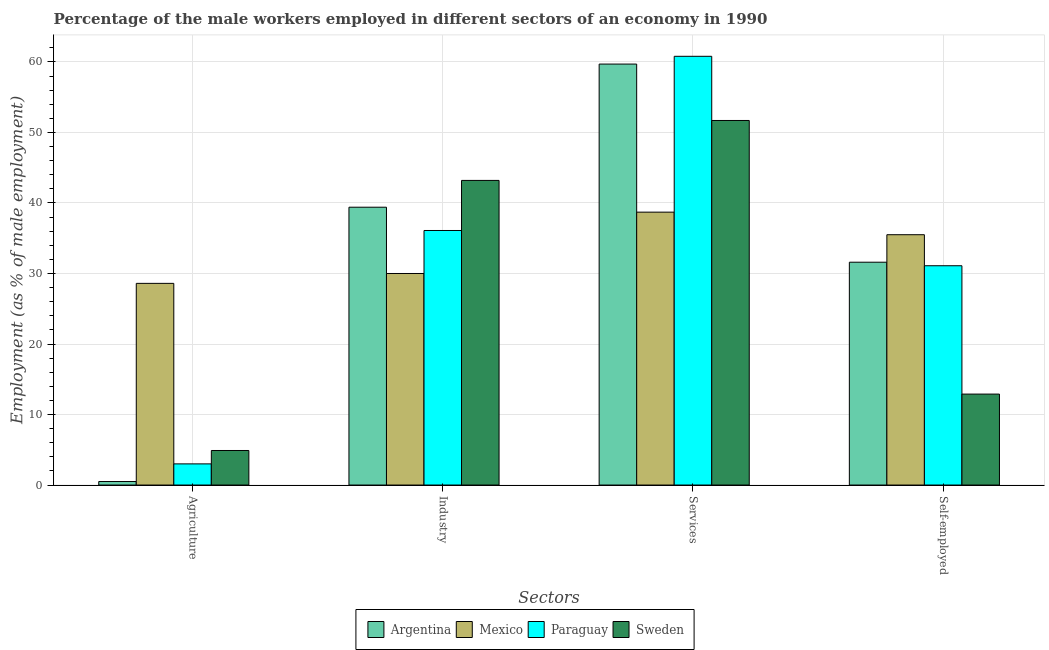How many different coloured bars are there?
Provide a succinct answer. 4. How many groups of bars are there?
Offer a very short reply. 4. Are the number of bars per tick equal to the number of legend labels?
Provide a succinct answer. Yes. Are the number of bars on each tick of the X-axis equal?
Your response must be concise. Yes. How many bars are there on the 1st tick from the left?
Your answer should be very brief. 4. How many bars are there on the 3rd tick from the right?
Provide a succinct answer. 4. What is the label of the 1st group of bars from the left?
Make the answer very short. Agriculture. What is the percentage of self employed male workers in Argentina?
Your answer should be very brief. 31.6. Across all countries, what is the maximum percentage of male workers in industry?
Your answer should be very brief. 43.2. Across all countries, what is the minimum percentage of male workers in agriculture?
Give a very brief answer. 0.5. In which country was the percentage of self employed male workers maximum?
Keep it short and to the point. Mexico. In which country was the percentage of male workers in services minimum?
Provide a succinct answer. Mexico. What is the total percentage of male workers in industry in the graph?
Your response must be concise. 148.7. What is the difference between the percentage of self employed male workers in Paraguay and that in Mexico?
Offer a terse response. -4.4. What is the difference between the percentage of male workers in agriculture in Sweden and the percentage of male workers in services in Mexico?
Provide a succinct answer. -33.8. What is the average percentage of male workers in agriculture per country?
Ensure brevity in your answer.  9.25. What is the difference between the percentage of self employed male workers and percentage of male workers in industry in Sweden?
Your answer should be very brief. -30.3. What is the ratio of the percentage of self employed male workers in Mexico to that in Paraguay?
Offer a very short reply. 1.14. Is the percentage of male workers in agriculture in Mexico less than that in Paraguay?
Give a very brief answer. No. What is the difference between the highest and the second highest percentage of male workers in agriculture?
Your answer should be compact. 23.7. What is the difference between the highest and the lowest percentage of male workers in industry?
Provide a short and direct response. 13.2. Is the sum of the percentage of self employed male workers in Paraguay and Mexico greater than the maximum percentage of male workers in services across all countries?
Give a very brief answer. Yes. What does the 2nd bar from the left in Services represents?
Your answer should be compact. Mexico. Is it the case that in every country, the sum of the percentage of male workers in agriculture and percentage of male workers in industry is greater than the percentage of male workers in services?
Give a very brief answer. No. How many bars are there?
Provide a succinct answer. 16. What is the difference between two consecutive major ticks on the Y-axis?
Make the answer very short. 10. Does the graph contain any zero values?
Offer a very short reply. No. Does the graph contain grids?
Provide a short and direct response. Yes. What is the title of the graph?
Provide a succinct answer. Percentage of the male workers employed in different sectors of an economy in 1990. What is the label or title of the X-axis?
Your response must be concise. Sectors. What is the label or title of the Y-axis?
Make the answer very short. Employment (as % of male employment). What is the Employment (as % of male employment) in Mexico in Agriculture?
Make the answer very short. 28.6. What is the Employment (as % of male employment) of Sweden in Agriculture?
Your answer should be very brief. 4.9. What is the Employment (as % of male employment) of Argentina in Industry?
Offer a terse response. 39.4. What is the Employment (as % of male employment) of Mexico in Industry?
Your answer should be compact. 30. What is the Employment (as % of male employment) in Paraguay in Industry?
Keep it short and to the point. 36.1. What is the Employment (as % of male employment) of Sweden in Industry?
Make the answer very short. 43.2. What is the Employment (as % of male employment) in Argentina in Services?
Your answer should be compact. 59.7. What is the Employment (as % of male employment) in Mexico in Services?
Your response must be concise. 38.7. What is the Employment (as % of male employment) of Paraguay in Services?
Provide a short and direct response. 60.8. What is the Employment (as % of male employment) of Sweden in Services?
Make the answer very short. 51.7. What is the Employment (as % of male employment) of Argentina in Self-employed?
Your answer should be very brief. 31.6. What is the Employment (as % of male employment) in Mexico in Self-employed?
Your answer should be compact. 35.5. What is the Employment (as % of male employment) of Paraguay in Self-employed?
Give a very brief answer. 31.1. What is the Employment (as % of male employment) in Sweden in Self-employed?
Offer a very short reply. 12.9. Across all Sectors, what is the maximum Employment (as % of male employment) in Argentina?
Offer a terse response. 59.7. Across all Sectors, what is the maximum Employment (as % of male employment) of Mexico?
Your answer should be very brief. 38.7. Across all Sectors, what is the maximum Employment (as % of male employment) of Paraguay?
Offer a terse response. 60.8. Across all Sectors, what is the maximum Employment (as % of male employment) in Sweden?
Make the answer very short. 51.7. Across all Sectors, what is the minimum Employment (as % of male employment) of Argentina?
Your response must be concise. 0.5. Across all Sectors, what is the minimum Employment (as % of male employment) in Mexico?
Offer a terse response. 28.6. Across all Sectors, what is the minimum Employment (as % of male employment) in Sweden?
Keep it short and to the point. 4.9. What is the total Employment (as % of male employment) of Argentina in the graph?
Offer a terse response. 131.2. What is the total Employment (as % of male employment) of Mexico in the graph?
Provide a succinct answer. 132.8. What is the total Employment (as % of male employment) in Paraguay in the graph?
Offer a very short reply. 131. What is the total Employment (as % of male employment) of Sweden in the graph?
Offer a terse response. 112.7. What is the difference between the Employment (as % of male employment) in Argentina in Agriculture and that in Industry?
Your answer should be very brief. -38.9. What is the difference between the Employment (as % of male employment) of Paraguay in Agriculture and that in Industry?
Provide a succinct answer. -33.1. What is the difference between the Employment (as % of male employment) in Sweden in Agriculture and that in Industry?
Ensure brevity in your answer.  -38.3. What is the difference between the Employment (as % of male employment) in Argentina in Agriculture and that in Services?
Your answer should be very brief. -59.2. What is the difference between the Employment (as % of male employment) of Mexico in Agriculture and that in Services?
Provide a short and direct response. -10.1. What is the difference between the Employment (as % of male employment) in Paraguay in Agriculture and that in Services?
Give a very brief answer. -57.8. What is the difference between the Employment (as % of male employment) in Sweden in Agriculture and that in Services?
Keep it short and to the point. -46.8. What is the difference between the Employment (as % of male employment) of Argentina in Agriculture and that in Self-employed?
Keep it short and to the point. -31.1. What is the difference between the Employment (as % of male employment) in Mexico in Agriculture and that in Self-employed?
Provide a short and direct response. -6.9. What is the difference between the Employment (as % of male employment) in Paraguay in Agriculture and that in Self-employed?
Your answer should be very brief. -28.1. What is the difference between the Employment (as % of male employment) of Argentina in Industry and that in Services?
Provide a short and direct response. -20.3. What is the difference between the Employment (as % of male employment) of Mexico in Industry and that in Services?
Give a very brief answer. -8.7. What is the difference between the Employment (as % of male employment) of Paraguay in Industry and that in Services?
Ensure brevity in your answer.  -24.7. What is the difference between the Employment (as % of male employment) of Argentina in Industry and that in Self-employed?
Your answer should be compact. 7.8. What is the difference between the Employment (as % of male employment) of Mexico in Industry and that in Self-employed?
Keep it short and to the point. -5.5. What is the difference between the Employment (as % of male employment) in Sweden in Industry and that in Self-employed?
Your response must be concise. 30.3. What is the difference between the Employment (as % of male employment) in Argentina in Services and that in Self-employed?
Your answer should be compact. 28.1. What is the difference between the Employment (as % of male employment) in Mexico in Services and that in Self-employed?
Make the answer very short. 3.2. What is the difference between the Employment (as % of male employment) in Paraguay in Services and that in Self-employed?
Offer a terse response. 29.7. What is the difference between the Employment (as % of male employment) in Sweden in Services and that in Self-employed?
Your answer should be compact. 38.8. What is the difference between the Employment (as % of male employment) of Argentina in Agriculture and the Employment (as % of male employment) of Mexico in Industry?
Keep it short and to the point. -29.5. What is the difference between the Employment (as % of male employment) in Argentina in Agriculture and the Employment (as % of male employment) in Paraguay in Industry?
Your answer should be very brief. -35.6. What is the difference between the Employment (as % of male employment) in Argentina in Agriculture and the Employment (as % of male employment) in Sweden in Industry?
Provide a short and direct response. -42.7. What is the difference between the Employment (as % of male employment) in Mexico in Agriculture and the Employment (as % of male employment) in Paraguay in Industry?
Keep it short and to the point. -7.5. What is the difference between the Employment (as % of male employment) of Mexico in Agriculture and the Employment (as % of male employment) of Sweden in Industry?
Ensure brevity in your answer.  -14.6. What is the difference between the Employment (as % of male employment) of Paraguay in Agriculture and the Employment (as % of male employment) of Sweden in Industry?
Offer a very short reply. -40.2. What is the difference between the Employment (as % of male employment) of Argentina in Agriculture and the Employment (as % of male employment) of Mexico in Services?
Keep it short and to the point. -38.2. What is the difference between the Employment (as % of male employment) of Argentina in Agriculture and the Employment (as % of male employment) of Paraguay in Services?
Make the answer very short. -60.3. What is the difference between the Employment (as % of male employment) of Argentina in Agriculture and the Employment (as % of male employment) of Sweden in Services?
Your response must be concise. -51.2. What is the difference between the Employment (as % of male employment) in Mexico in Agriculture and the Employment (as % of male employment) in Paraguay in Services?
Your response must be concise. -32.2. What is the difference between the Employment (as % of male employment) in Mexico in Agriculture and the Employment (as % of male employment) in Sweden in Services?
Keep it short and to the point. -23.1. What is the difference between the Employment (as % of male employment) of Paraguay in Agriculture and the Employment (as % of male employment) of Sweden in Services?
Offer a terse response. -48.7. What is the difference between the Employment (as % of male employment) of Argentina in Agriculture and the Employment (as % of male employment) of Mexico in Self-employed?
Your answer should be very brief. -35. What is the difference between the Employment (as % of male employment) of Argentina in Agriculture and the Employment (as % of male employment) of Paraguay in Self-employed?
Offer a very short reply. -30.6. What is the difference between the Employment (as % of male employment) in Argentina in Agriculture and the Employment (as % of male employment) in Sweden in Self-employed?
Your answer should be very brief. -12.4. What is the difference between the Employment (as % of male employment) in Mexico in Agriculture and the Employment (as % of male employment) in Sweden in Self-employed?
Provide a succinct answer. 15.7. What is the difference between the Employment (as % of male employment) in Argentina in Industry and the Employment (as % of male employment) in Paraguay in Services?
Offer a very short reply. -21.4. What is the difference between the Employment (as % of male employment) of Mexico in Industry and the Employment (as % of male employment) of Paraguay in Services?
Offer a terse response. -30.8. What is the difference between the Employment (as % of male employment) in Mexico in Industry and the Employment (as % of male employment) in Sweden in Services?
Make the answer very short. -21.7. What is the difference between the Employment (as % of male employment) of Paraguay in Industry and the Employment (as % of male employment) of Sweden in Services?
Your answer should be compact. -15.6. What is the difference between the Employment (as % of male employment) of Argentina in Industry and the Employment (as % of male employment) of Paraguay in Self-employed?
Make the answer very short. 8.3. What is the difference between the Employment (as % of male employment) in Mexico in Industry and the Employment (as % of male employment) in Paraguay in Self-employed?
Your answer should be very brief. -1.1. What is the difference between the Employment (as % of male employment) of Mexico in Industry and the Employment (as % of male employment) of Sweden in Self-employed?
Offer a very short reply. 17.1. What is the difference between the Employment (as % of male employment) in Paraguay in Industry and the Employment (as % of male employment) in Sweden in Self-employed?
Offer a terse response. 23.2. What is the difference between the Employment (as % of male employment) of Argentina in Services and the Employment (as % of male employment) of Mexico in Self-employed?
Provide a short and direct response. 24.2. What is the difference between the Employment (as % of male employment) of Argentina in Services and the Employment (as % of male employment) of Paraguay in Self-employed?
Keep it short and to the point. 28.6. What is the difference between the Employment (as % of male employment) in Argentina in Services and the Employment (as % of male employment) in Sweden in Self-employed?
Ensure brevity in your answer.  46.8. What is the difference between the Employment (as % of male employment) of Mexico in Services and the Employment (as % of male employment) of Sweden in Self-employed?
Give a very brief answer. 25.8. What is the difference between the Employment (as % of male employment) in Paraguay in Services and the Employment (as % of male employment) in Sweden in Self-employed?
Provide a short and direct response. 47.9. What is the average Employment (as % of male employment) of Argentina per Sectors?
Offer a very short reply. 32.8. What is the average Employment (as % of male employment) of Mexico per Sectors?
Ensure brevity in your answer.  33.2. What is the average Employment (as % of male employment) in Paraguay per Sectors?
Offer a very short reply. 32.75. What is the average Employment (as % of male employment) of Sweden per Sectors?
Offer a very short reply. 28.18. What is the difference between the Employment (as % of male employment) in Argentina and Employment (as % of male employment) in Mexico in Agriculture?
Give a very brief answer. -28.1. What is the difference between the Employment (as % of male employment) in Mexico and Employment (as % of male employment) in Paraguay in Agriculture?
Provide a short and direct response. 25.6. What is the difference between the Employment (as % of male employment) of Mexico and Employment (as % of male employment) of Sweden in Agriculture?
Provide a succinct answer. 23.7. What is the difference between the Employment (as % of male employment) in Paraguay and Employment (as % of male employment) in Sweden in Agriculture?
Provide a short and direct response. -1.9. What is the difference between the Employment (as % of male employment) of Argentina and Employment (as % of male employment) of Paraguay in Industry?
Your answer should be compact. 3.3. What is the difference between the Employment (as % of male employment) in Mexico and Employment (as % of male employment) in Sweden in Industry?
Make the answer very short. -13.2. What is the difference between the Employment (as % of male employment) of Argentina and Employment (as % of male employment) of Mexico in Services?
Make the answer very short. 21. What is the difference between the Employment (as % of male employment) of Argentina and Employment (as % of male employment) of Sweden in Services?
Your answer should be very brief. 8. What is the difference between the Employment (as % of male employment) in Mexico and Employment (as % of male employment) in Paraguay in Services?
Make the answer very short. -22.1. What is the difference between the Employment (as % of male employment) in Argentina and Employment (as % of male employment) in Paraguay in Self-employed?
Ensure brevity in your answer.  0.5. What is the difference between the Employment (as % of male employment) of Mexico and Employment (as % of male employment) of Sweden in Self-employed?
Ensure brevity in your answer.  22.6. What is the difference between the Employment (as % of male employment) in Paraguay and Employment (as % of male employment) in Sweden in Self-employed?
Your answer should be compact. 18.2. What is the ratio of the Employment (as % of male employment) of Argentina in Agriculture to that in Industry?
Your response must be concise. 0.01. What is the ratio of the Employment (as % of male employment) in Mexico in Agriculture to that in Industry?
Give a very brief answer. 0.95. What is the ratio of the Employment (as % of male employment) of Paraguay in Agriculture to that in Industry?
Your answer should be compact. 0.08. What is the ratio of the Employment (as % of male employment) in Sweden in Agriculture to that in Industry?
Your answer should be very brief. 0.11. What is the ratio of the Employment (as % of male employment) of Argentina in Agriculture to that in Services?
Give a very brief answer. 0.01. What is the ratio of the Employment (as % of male employment) of Mexico in Agriculture to that in Services?
Offer a terse response. 0.74. What is the ratio of the Employment (as % of male employment) of Paraguay in Agriculture to that in Services?
Your answer should be very brief. 0.05. What is the ratio of the Employment (as % of male employment) in Sweden in Agriculture to that in Services?
Give a very brief answer. 0.09. What is the ratio of the Employment (as % of male employment) of Argentina in Agriculture to that in Self-employed?
Give a very brief answer. 0.02. What is the ratio of the Employment (as % of male employment) in Mexico in Agriculture to that in Self-employed?
Provide a short and direct response. 0.81. What is the ratio of the Employment (as % of male employment) of Paraguay in Agriculture to that in Self-employed?
Provide a succinct answer. 0.1. What is the ratio of the Employment (as % of male employment) of Sweden in Agriculture to that in Self-employed?
Offer a very short reply. 0.38. What is the ratio of the Employment (as % of male employment) of Argentina in Industry to that in Services?
Your answer should be compact. 0.66. What is the ratio of the Employment (as % of male employment) in Mexico in Industry to that in Services?
Your answer should be very brief. 0.78. What is the ratio of the Employment (as % of male employment) of Paraguay in Industry to that in Services?
Your response must be concise. 0.59. What is the ratio of the Employment (as % of male employment) in Sweden in Industry to that in Services?
Your response must be concise. 0.84. What is the ratio of the Employment (as % of male employment) in Argentina in Industry to that in Self-employed?
Your response must be concise. 1.25. What is the ratio of the Employment (as % of male employment) in Mexico in Industry to that in Self-employed?
Give a very brief answer. 0.85. What is the ratio of the Employment (as % of male employment) of Paraguay in Industry to that in Self-employed?
Keep it short and to the point. 1.16. What is the ratio of the Employment (as % of male employment) of Sweden in Industry to that in Self-employed?
Offer a terse response. 3.35. What is the ratio of the Employment (as % of male employment) of Argentina in Services to that in Self-employed?
Ensure brevity in your answer.  1.89. What is the ratio of the Employment (as % of male employment) of Mexico in Services to that in Self-employed?
Your answer should be compact. 1.09. What is the ratio of the Employment (as % of male employment) of Paraguay in Services to that in Self-employed?
Provide a short and direct response. 1.96. What is the ratio of the Employment (as % of male employment) in Sweden in Services to that in Self-employed?
Offer a terse response. 4.01. What is the difference between the highest and the second highest Employment (as % of male employment) of Argentina?
Ensure brevity in your answer.  20.3. What is the difference between the highest and the second highest Employment (as % of male employment) of Paraguay?
Your answer should be compact. 24.7. What is the difference between the highest and the lowest Employment (as % of male employment) of Argentina?
Provide a short and direct response. 59.2. What is the difference between the highest and the lowest Employment (as % of male employment) of Paraguay?
Your answer should be very brief. 57.8. What is the difference between the highest and the lowest Employment (as % of male employment) in Sweden?
Offer a terse response. 46.8. 